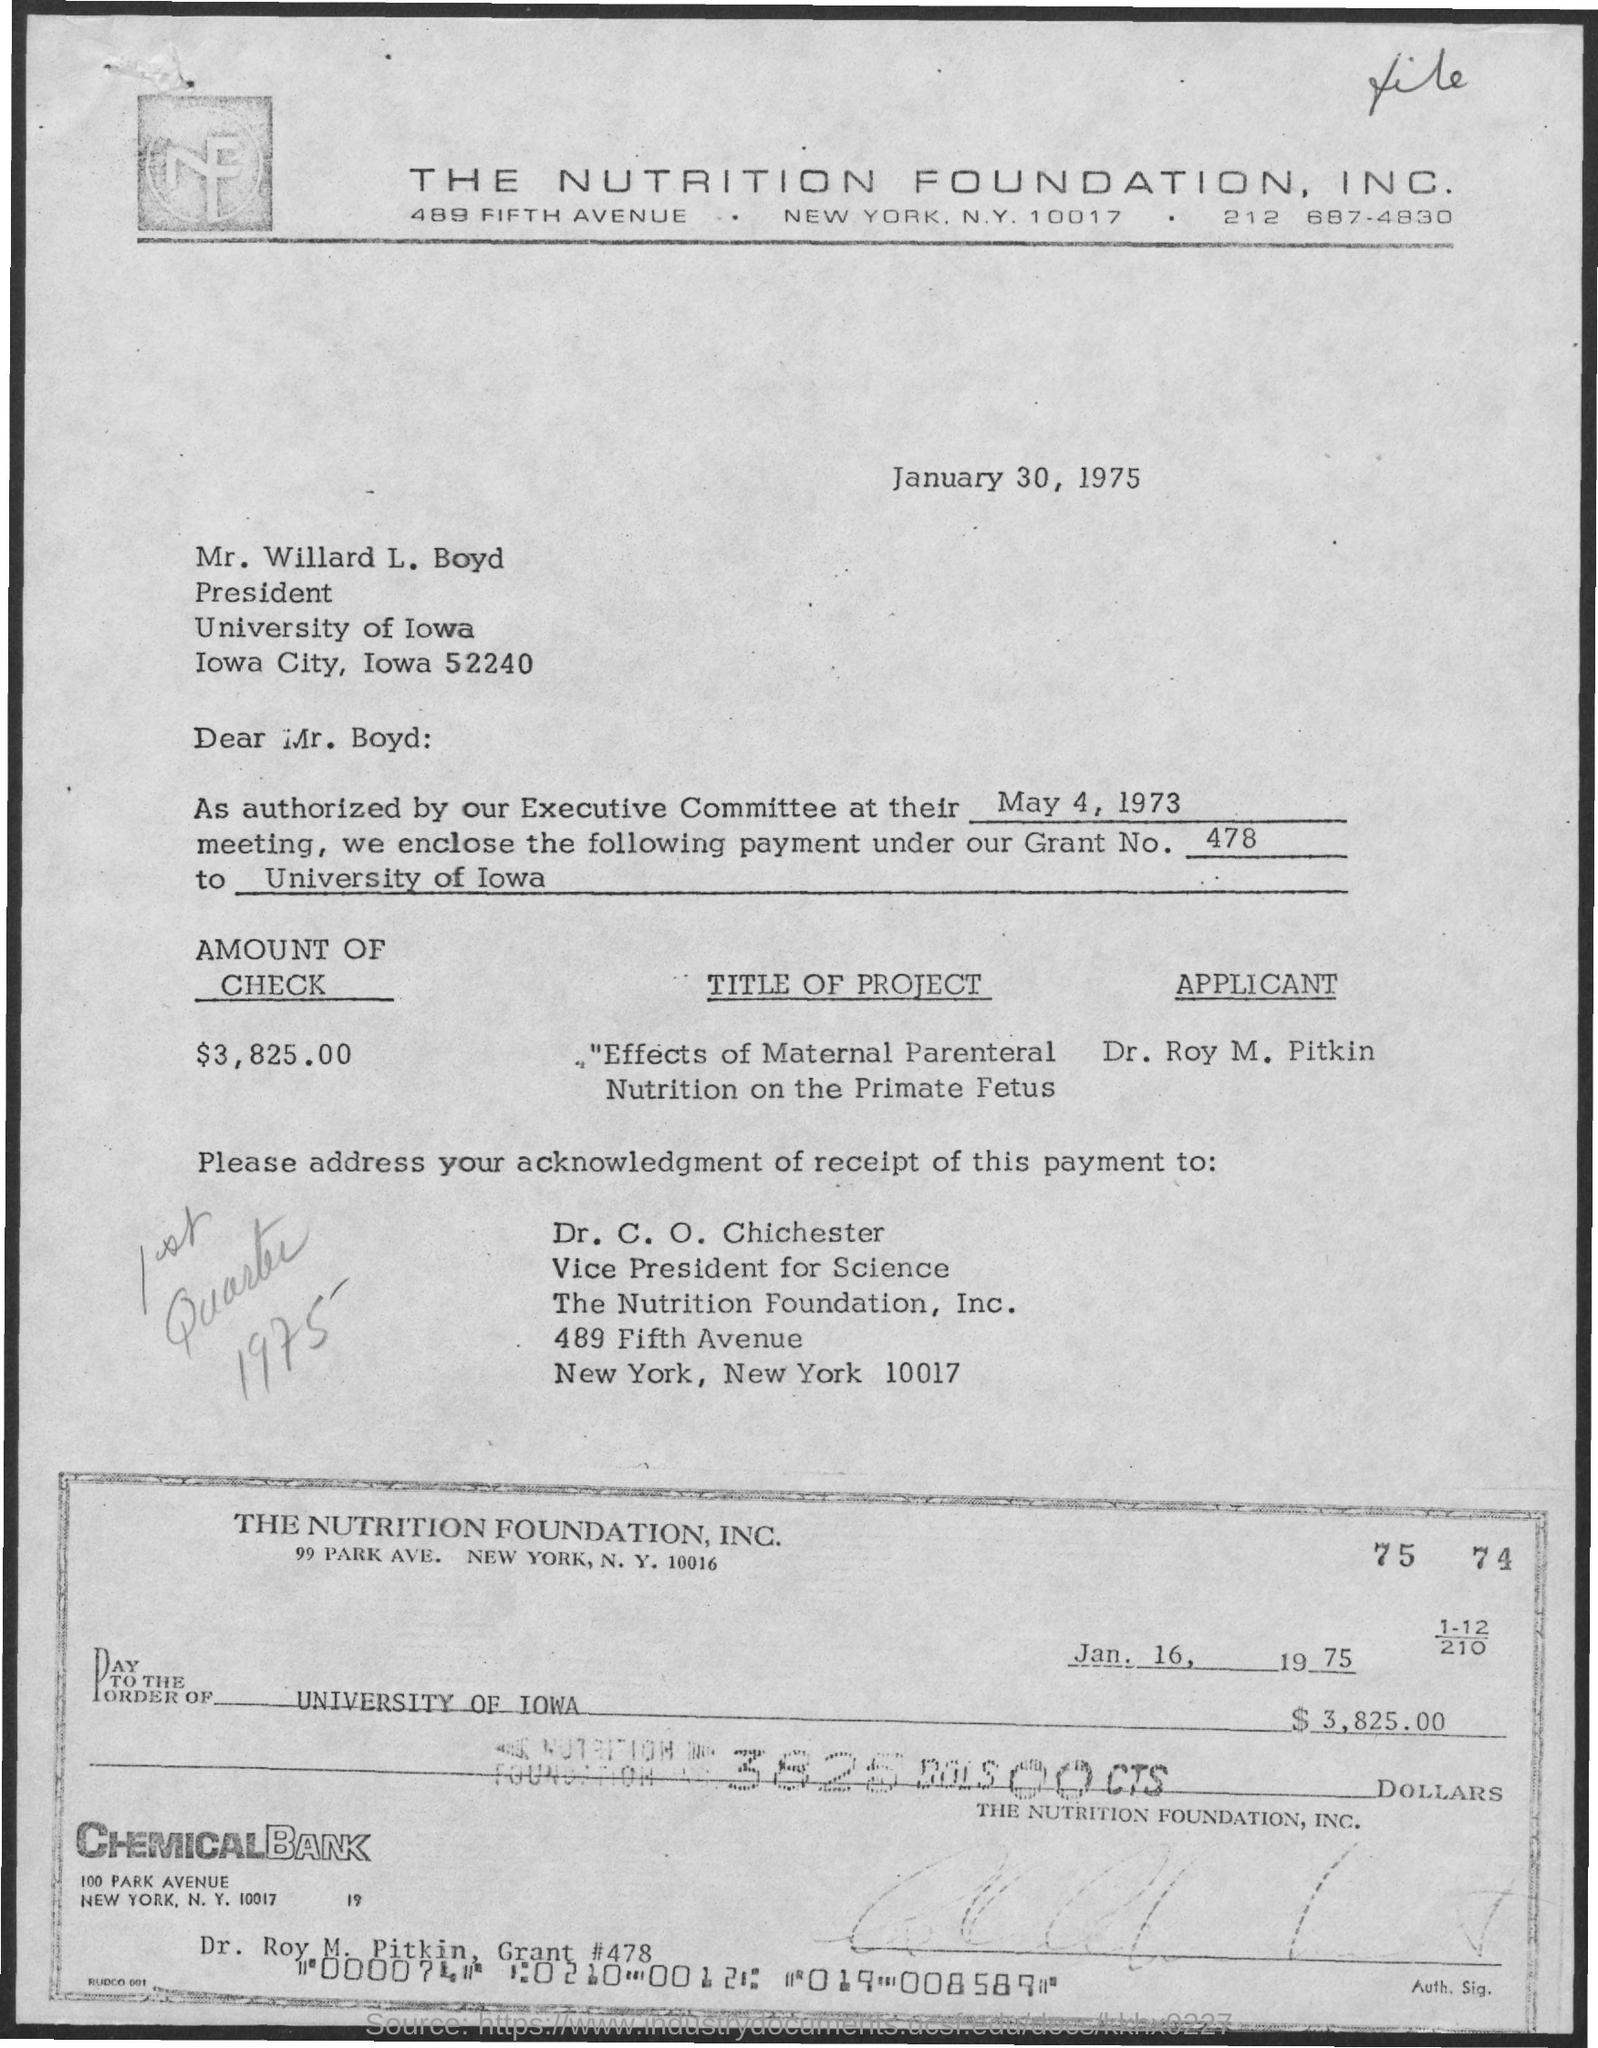What is the grant number mentioned in the given letter ?
Offer a very short reply. 478. What is the amount of check given in the letter ?
Your answer should be compact. $3,825.00. What is the title of the project given in the letter ?
Provide a succinct answer. "effects of maternal parenteral  nutrition on the primate Fetus. What is the date mentioned in the given check ?
Provide a short and direct response. Jan. 16, 1975. 